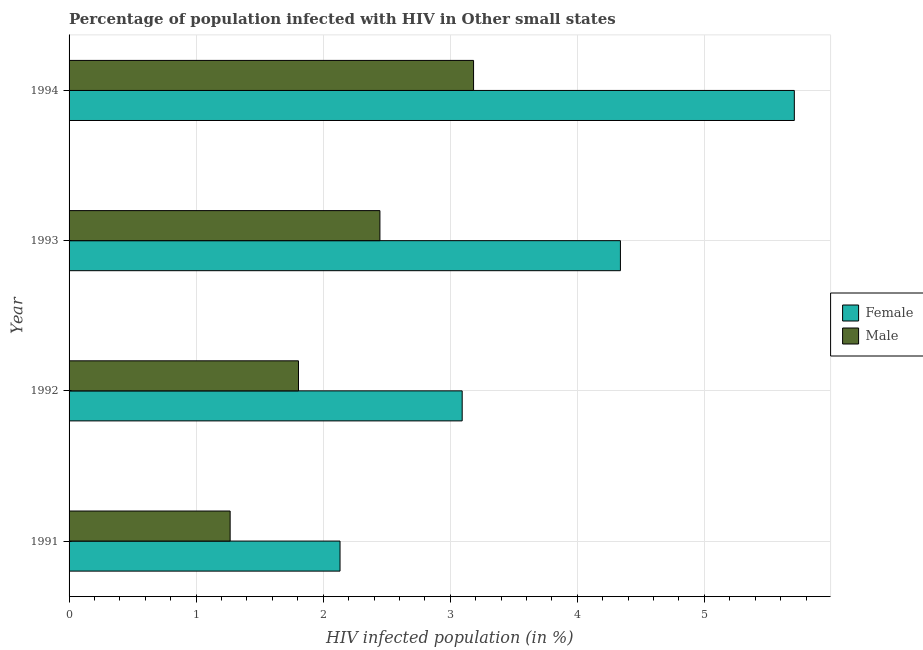How many groups of bars are there?
Provide a succinct answer. 4. Are the number of bars on each tick of the Y-axis equal?
Give a very brief answer. Yes. What is the percentage of females who are infected with hiv in 1993?
Your response must be concise. 4.34. Across all years, what is the maximum percentage of males who are infected with hiv?
Ensure brevity in your answer.  3.18. Across all years, what is the minimum percentage of males who are infected with hiv?
Give a very brief answer. 1.27. What is the total percentage of males who are infected with hiv in the graph?
Your answer should be very brief. 8.7. What is the difference between the percentage of females who are infected with hiv in 1992 and that in 1994?
Your response must be concise. -2.61. What is the difference between the percentage of males who are infected with hiv in 1993 and the percentage of females who are infected with hiv in 1991?
Offer a very short reply. 0.31. What is the average percentage of females who are infected with hiv per year?
Keep it short and to the point. 3.82. In the year 1992, what is the difference between the percentage of females who are infected with hiv and percentage of males who are infected with hiv?
Provide a succinct answer. 1.29. In how many years, is the percentage of females who are infected with hiv greater than 1.8 %?
Ensure brevity in your answer.  4. What is the ratio of the percentage of males who are infected with hiv in 1991 to that in 1994?
Keep it short and to the point. 0.4. What is the difference between the highest and the second highest percentage of females who are infected with hiv?
Give a very brief answer. 1.37. What is the difference between the highest and the lowest percentage of females who are infected with hiv?
Provide a succinct answer. 3.58. In how many years, is the percentage of females who are infected with hiv greater than the average percentage of females who are infected with hiv taken over all years?
Your answer should be compact. 2. Is the sum of the percentage of males who are infected with hiv in 1993 and 1994 greater than the maximum percentage of females who are infected with hiv across all years?
Your response must be concise. No. What does the 1st bar from the top in 1991 represents?
Offer a very short reply. Male. What does the 1st bar from the bottom in 1992 represents?
Make the answer very short. Female. Are all the bars in the graph horizontal?
Your answer should be very brief. Yes. How many years are there in the graph?
Your response must be concise. 4. What is the difference between two consecutive major ticks on the X-axis?
Keep it short and to the point. 1. Are the values on the major ticks of X-axis written in scientific E-notation?
Provide a short and direct response. No. Does the graph contain grids?
Offer a very short reply. Yes. Where does the legend appear in the graph?
Ensure brevity in your answer.  Center right. How many legend labels are there?
Provide a short and direct response. 2. How are the legend labels stacked?
Provide a short and direct response. Vertical. What is the title of the graph?
Offer a very short reply. Percentage of population infected with HIV in Other small states. What is the label or title of the X-axis?
Provide a short and direct response. HIV infected population (in %). What is the HIV infected population (in %) in Female in 1991?
Provide a succinct answer. 2.13. What is the HIV infected population (in %) in Male in 1991?
Keep it short and to the point. 1.27. What is the HIV infected population (in %) of Female in 1992?
Keep it short and to the point. 3.09. What is the HIV infected population (in %) in Male in 1992?
Give a very brief answer. 1.81. What is the HIV infected population (in %) in Female in 1993?
Provide a succinct answer. 4.34. What is the HIV infected population (in %) in Male in 1993?
Make the answer very short. 2.45. What is the HIV infected population (in %) of Female in 1994?
Your answer should be compact. 5.71. What is the HIV infected population (in %) in Male in 1994?
Your answer should be compact. 3.18. Across all years, what is the maximum HIV infected population (in %) in Female?
Make the answer very short. 5.71. Across all years, what is the maximum HIV infected population (in %) in Male?
Your answer should be very brief. 3.18. Across all years, what is the minimum HIV infected population (in %) in Female?
Your answer should be compact. 2.13. Across all years, what is the minimum HIV infected population (in %) in Male?
Your response must be concise. 1.27. What is the total HIV infected population (in %) of Female in the graph?
Offer a very short reply. 15.27. What is the total HIV infected population (in %) in Male in the graph?
Your answer should be very brief. 8.7. What is the difference between the HIV infected population (in %) in Female in 1991 and that in 1992?
Offer a terse response. -0.96. What is the difference between the HIV infected population (in %) in Male in 1991 and that in 1992?
Ensure brevity in your answer.  -0.54. What is the difference between the HIV infected population (in %) of Female in 1991 and that in 1993?
Offer a very short reply. -2.21. What is the difference between the HIV infected population (in %) in Male in 1991 and that in 1993?
Give a very brief answer. -1.18. What is the difference between the HIV infected population (in %) in Female in 1991 and that in 1994?
Your response must be concise. -3.58. What is the difference between the HIV infected population (in %) in Male in 1991 and that in 1994?
Offer a very short reply. -1.92. What is the difference between the HIV infected population (in %) in Female in 1992 and that in 1993?
Your answer should be compact. -1.25. What is the difference between the HIV infected population (in %) in Male in 1992 and that in 1993?
Make the answer very short. -0.64. What is the difference between the HIV infected population (in %) of Female in 1992 and that in 1994?
Offer a very short reply. -2.61. What is the difference between the HIV infected population (in %) in Male in 1992 and that in 1994?
Make the answer very short. -1.38. What is the difference between the HIV infected population (in %) of Female in 1993 and that in 1994?
Ensure brevity in your answer.  -1.37. What is the difference between the HIV infected population (in %) of Male in 1993 and that in 1994?
Your answer should be very brief. -0.74. What is the difference between the HIV infected population (in %) of Female in 1991 and the HIV infected population (in %) of Male in 1992?
Offer a very short reply. 0.33. What is the difference between the HIV infected population (in %) of Female in 1991 and the HIV infected population (in %) of Male in 1993?
Give a very brief answer. -0.31. What is the difference between the HIV infected population (in %) in Female in 1991 and the HIV infected population (in %) in Male in 1994?
Make the answer very short. -1.05. What is the difference between the HIV infected population (in %) of Female in 1992 and the HIV infected population (in %) of Male in 1993?
Offer a very short reply. 0.65. What is the difference between the HIV infected population (in %) in Female in 1992 and the HIV infected population (in %) in Male in 1994?
Keep it short and to the point. -0.09. What is the difference between the HIV infected population (in %) of Female in 1993 and the HIV infected population (in %) of Male in 1994?
Offer a terse response. 1.16. What is the average HIV infected population (in %) in Female per year?
Your answer should be very brief. 3.82. What is the average HIV infected population (in %) of Male per year?
Your answer should be compact. 2.18. In the year 1991, what is the difference between the HIV infected population (in %) in Female and HIV infected population (in %) in Male?
Your answer should be compact. 0.86. In the year 1992, what is the difference between the HIV infected population (in %) of Female and HIV infected population (in %) of Male?
Provide a succinct answer. 1.29. In the year 1993, what is the difference between the HIV infected population (in %) of Female and HIV infected population (in %) of Male?
Provide a succinct answer. 1.89. In the year 1994, what is the difference between the HIV infected population (in %) in Female and HIV infected population (in %) in Male?
Your response must be concise. 2.52. What is the ratio of the HIV infected population (in %) of Female in 1991 to that in 1992?
Offer a terse response. 0.69. What is the ratio of the HIV infected population (in %) of Male in 1991 to that in 1992?
Your answer should be very brief. 0.7. What is the ratio of the HIV infected population (in %) of Female in 1991 to that in 1993?
Your response must be concise. 0.49. What is the ratio of the HIV infected population (in %) of Male in 1991 to that in 1993?
Your answer should be compact. 0.52. What is the ratio of the HIV infected population (in %) in Female in 1991 to that in 1994?
Give a very brief answer. 0.37. What is the ratio of the HIV infected population (in %) in Male in 1991 to that in 1994?
Provide a short and direct response. 0.4. What is the ratio of the HIV infected population (in %) in Female in 1992 to that in 1993?
Provide a succinct answer. 0.71. What is the ratio of the HIV infected population (in %) in Male in 1992 to that in 1993?
Ensure brevity in your answer.  0.74. What is the ratio of the HIV infected population (in %) of Female in 1992 to that in 1994?
Provide a short and direct response. 0.54. What is the ratio of the HIV infected population (in %) of Male in 1992 to that in 1994?
Make the answer very short. 0.57. What is the ratio of the HIV infected population (in %) of Female in 1993 to that in 1994?
Your response must be concise. 0.76. What is the ratio of the HIV infected population (in %) of Male in 1993 to that in 1994?
Ensure brevity in your answer.  0.77. What is the difference between the highest and the second highest HIV infected population (in %) of Female?
Offer a very short reply. 1.37. What is the difference between the highest and the second highest HIV infected population (in %) in Male?
Make the answer very short. 0.74. What is the difference between the highest and the lowest HIV infected population (in %) of Female?
Make the answer very short. 3.58. What is the difference between the highest and the lowest HIV infected population (in %) of Male?
Give a very brief answer. 1.92. 